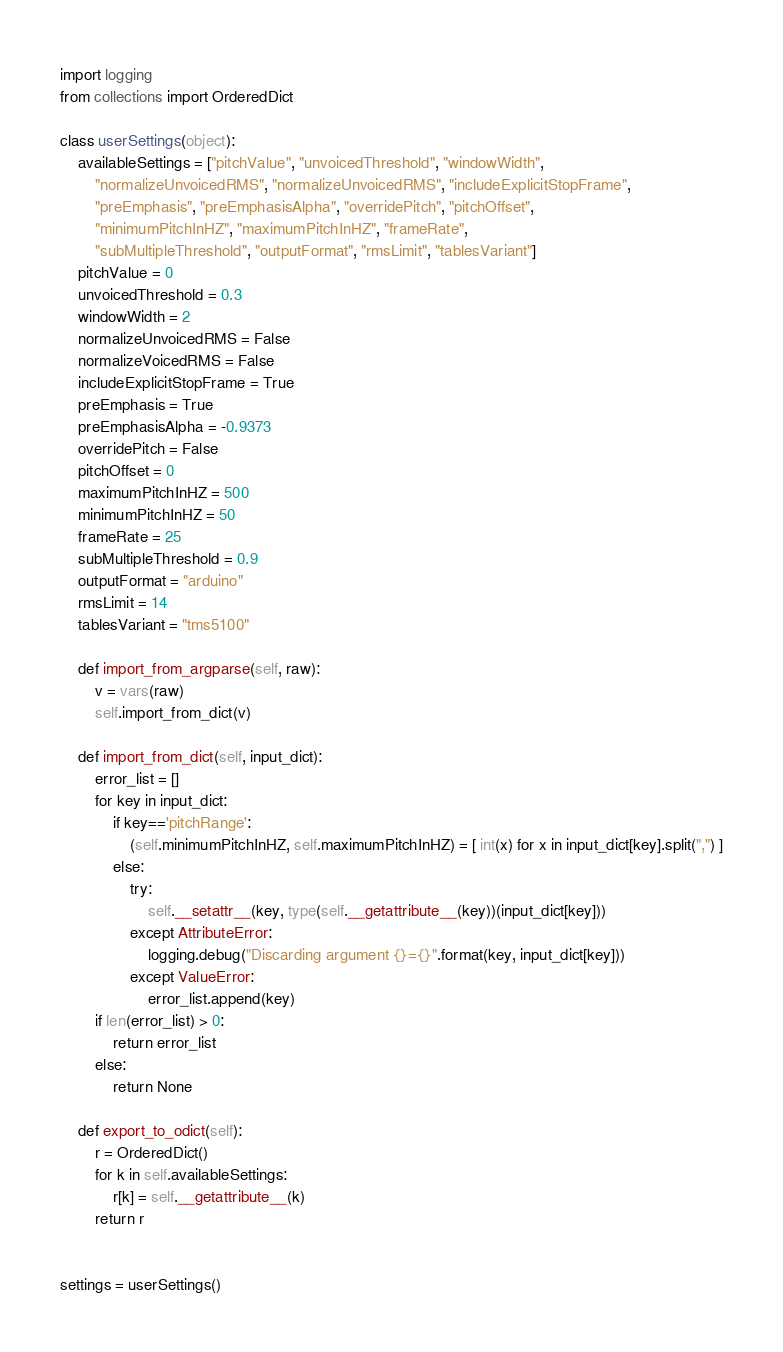Convert code to text. <code><loc_0><loc_0><loc_500><loc_500><_Python_>import logging
from collections import OrderedDict

class userSettings(object):
    availableSettings = ["pitchValue", "unvoicedThreshold", "windowWidth",
        "normalizeUnvoicedRMS", "normalizeUnvoicedRMS", "includeExplicitStopFrame",
        "preEmphasis", "preEmphasisAlpha", "overridePitch", "pitchOffset",
        "minimumPitchInHZ", "maximumPitchInHZ", "frameRate",
        "subMultipleThreshold", "outputFormat", "rmsLimit", "tablesVariant"]
    pitchValue = 0
    unvoicedThreshold = 0.3
    windowWidth = 2
    normalizeUnvoicedRMS = False
    normalizeVoicedRMS = False
    includeExplicitStopFrame = True
    preEmphasis = True
    preEmphasisAlpha = -0.9373
    overridePitch = False
    pitchOffset = 0
    maximumPitchInHZ = 500
    minimumPitchInHZ = 50
    frameRate = 25
    subMultipleThreshold = 0.9
    outputFormat = "arduino"
    rmsLimit = 14
    tablesVariant = "tms5100"

    def import_from_argparse(self, raw):
        v = vars(raw)
        self.import_from_dict(v)

    def import_from_dict(self, input_dict):
        error_list = []
        for key in input_dict:
            if key=='pitchRange':
                (self.minimumPitchInHZ, self.maximumPitchInHZ) = [ int(x) for x in input_dict[key].split(",") ]
            else:
                try:
                    self.__setattr__(key, type(self.__getattribute__(key))(input_dict[key]))
                except AttributeError:
                    logging.debug("Discarding argument {}={}".format(key, input_dict[key]))
                except ValueError:
                    error_list.append(key)
        if len(error_list) > 0:
            return error_list
        else:
            return None

    def export_to_odict(self):
        r = OrderedDict()
        for k in self.availableSettings:
            r[k] = self.__getattribute__(k)
        return r


settings = userSettings()

</code> 